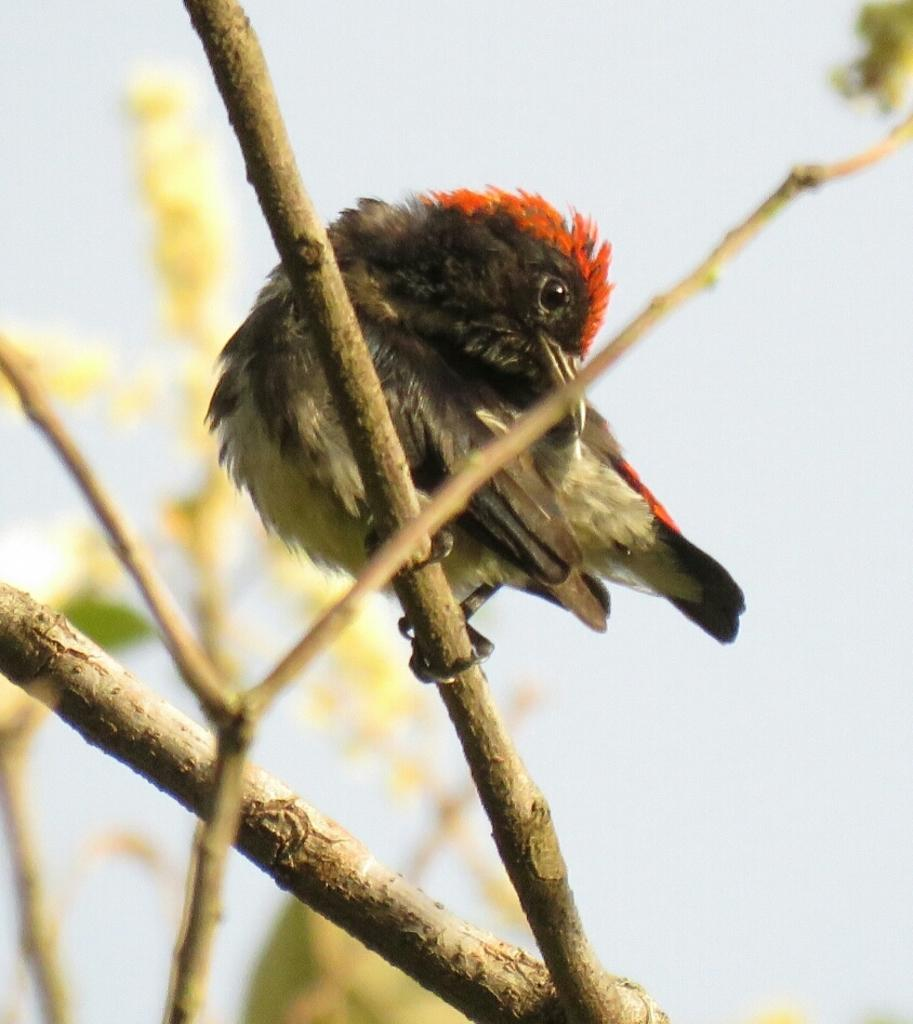What type of animal can be seen in the image? There is a bird in the image. Where is the bird located? The bird is on a branch of a tree. What fact about the bird's parent can be observed in the image? There is no information about the bird's parent in the image, as it only shows the bird on a branch. 